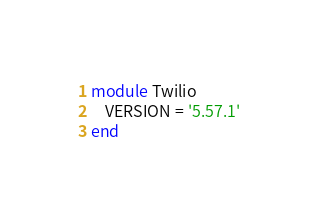<code> <loc_0><loc_0><loc_500><loc_500><_Ruby_>module Twilio
    VERSION = '5.57.1'
end
</code> 